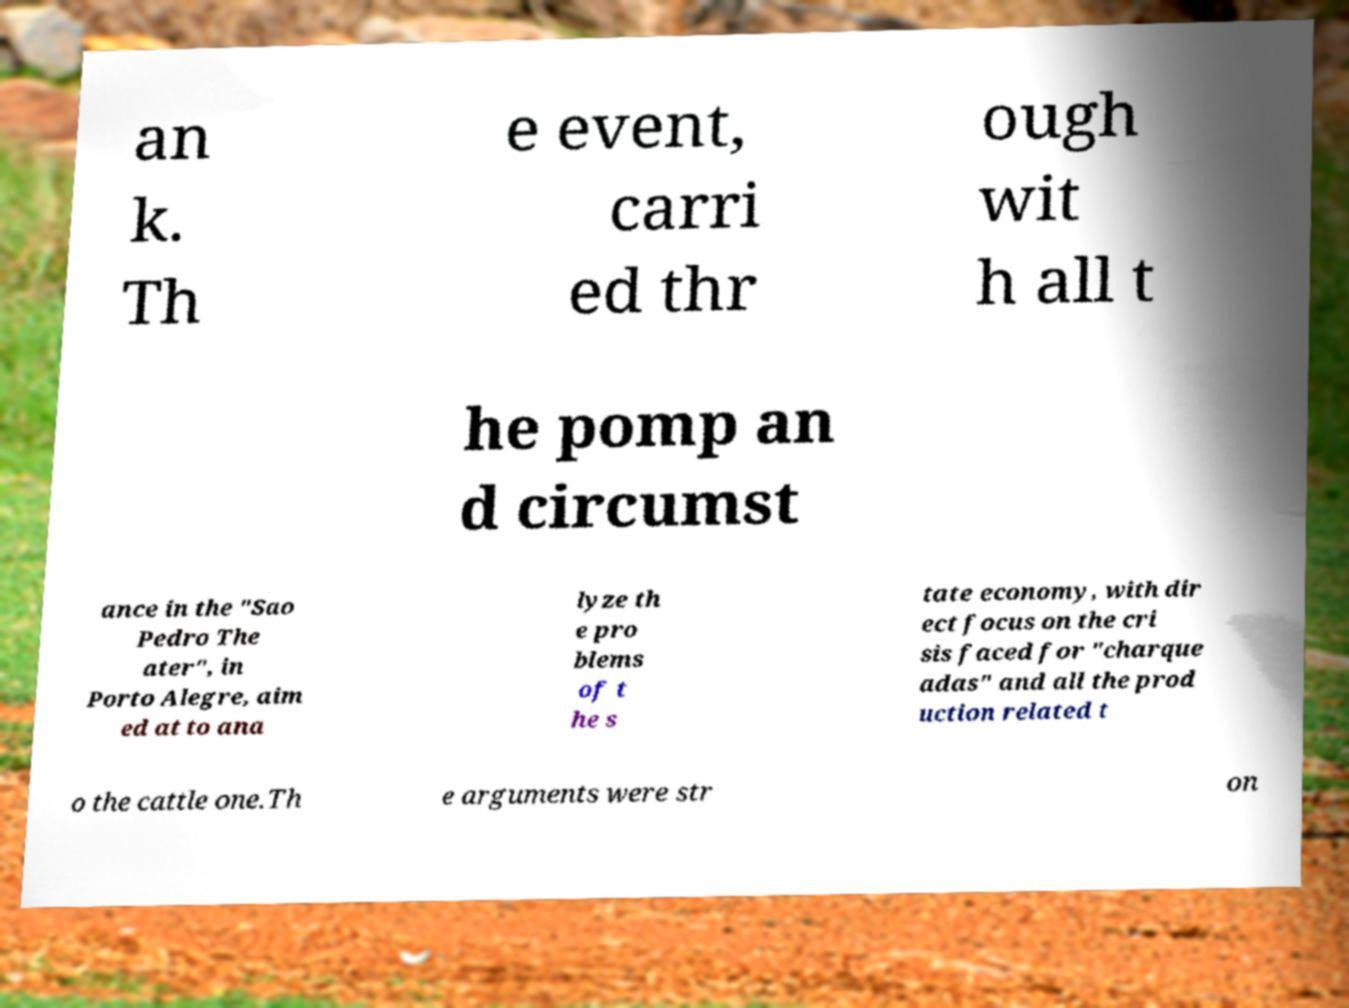For documentation purposes, I need the text within this image transcribed. Could you provide that? an k. Th e event, carri ed thr ough wit h all t he pomp an d circumst ance in the "Sao Pedro The ater", in Porto Alegre, aim ed at to ana lyze th e pro blems of t he s tate economy, with dir ect focus on the cri sis faced for "charque adas" and all the prod uction related t o the cattle one.Th e arguments were str on 